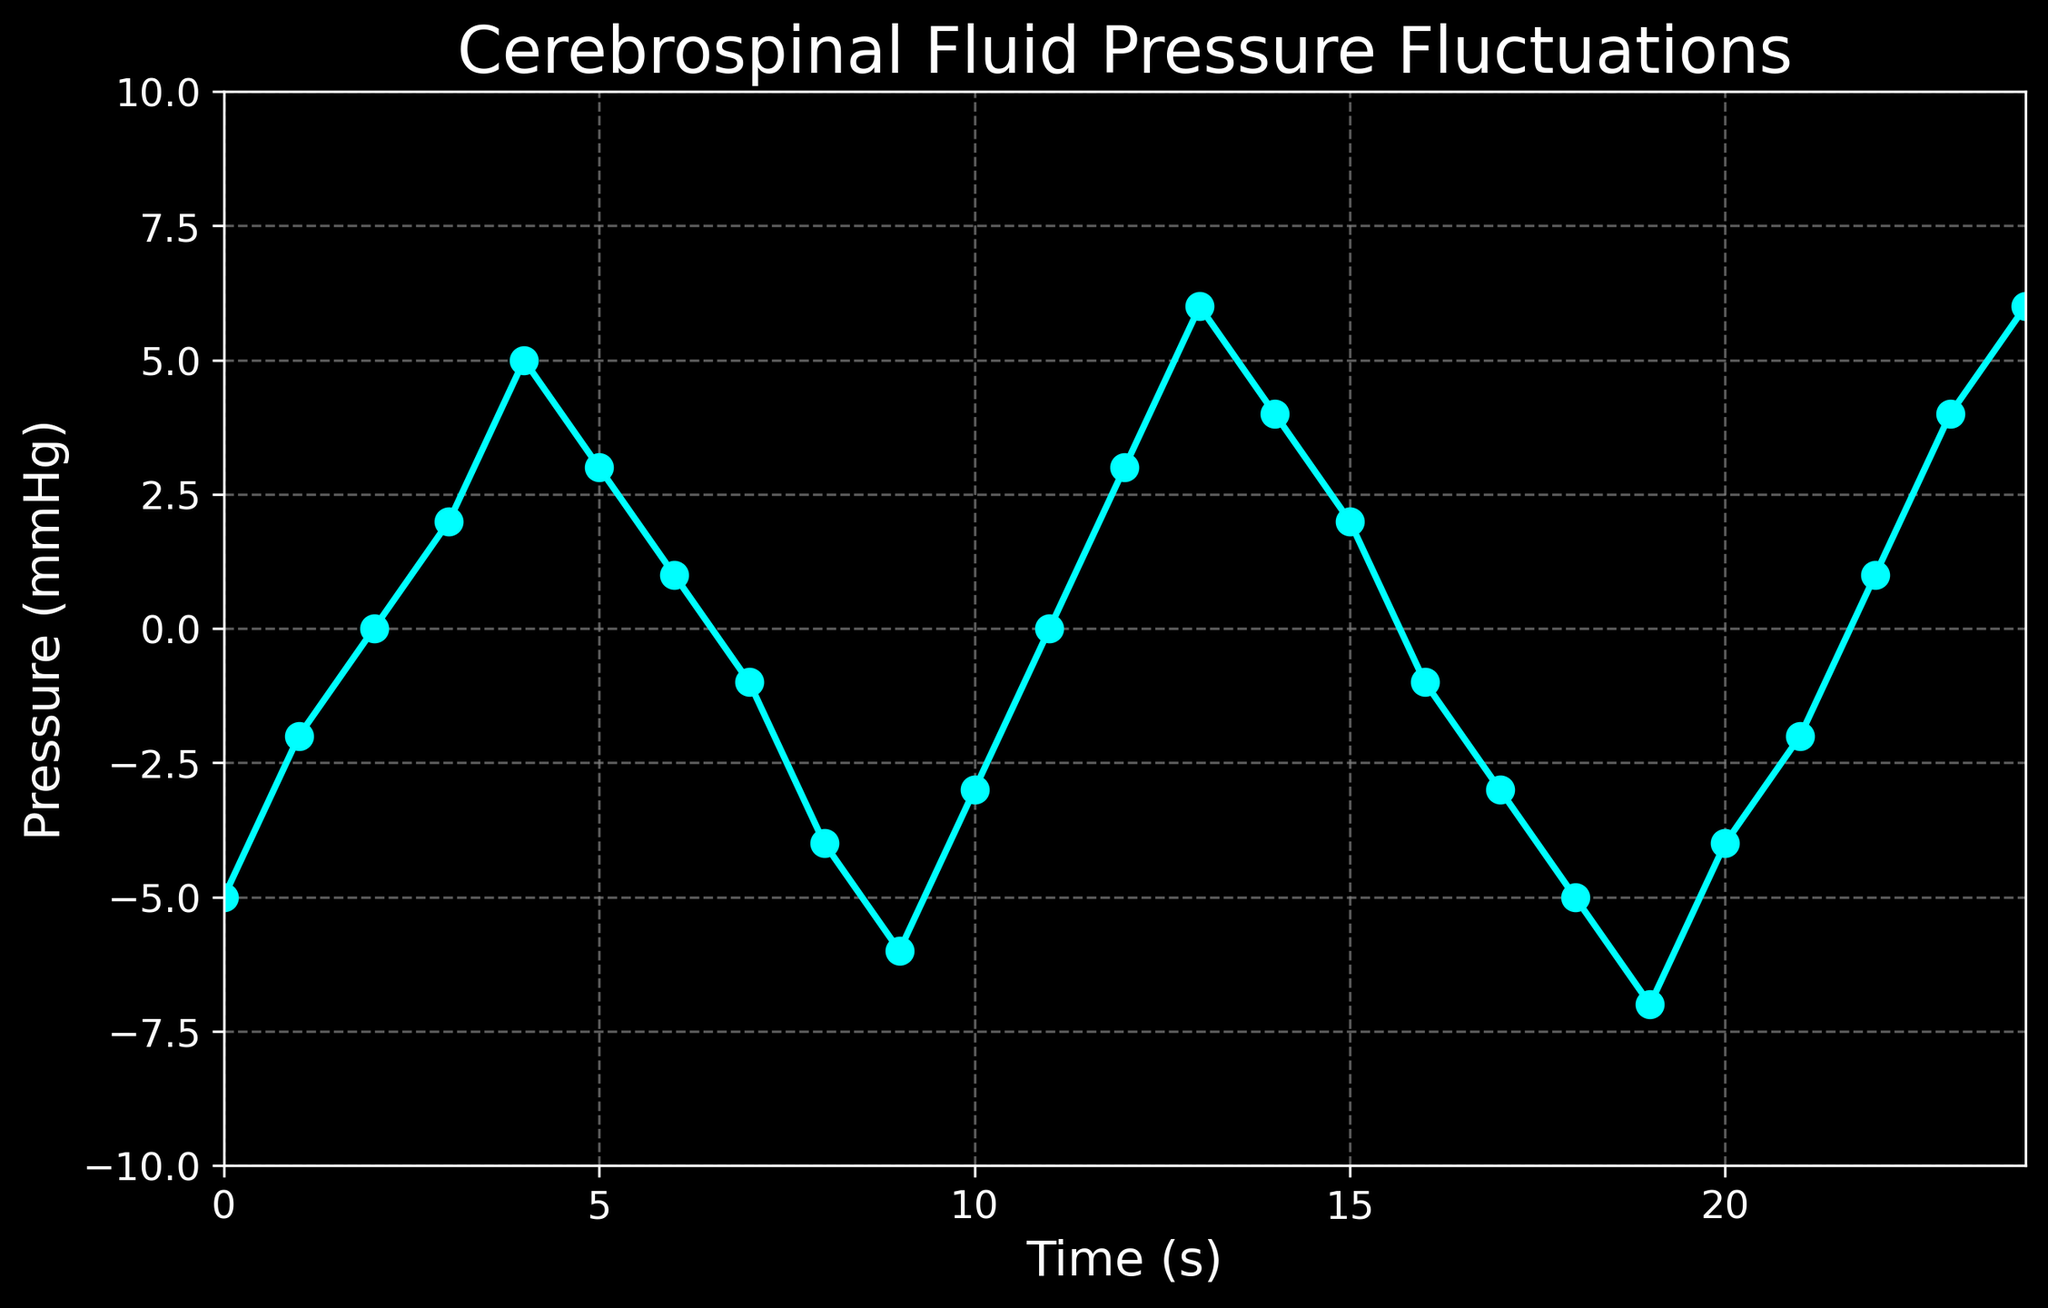What is the pressure at time 8 seconds? Look at the curve where the x-axis is 8 seconds and observe the corresponding y-axis value for pressure. You can see that it is -4 mmHg.
Answer: -4 mmHg What is the maximum pressure recorded, and at what time does it occur? Examine the pressure values throughout the entire graph and identify the highest point. The maximum pressure of 6 mmHg occurs at time 13 seconds and 24 seconds.
Answer: 6 mmHg at 13 seconds and 24 seconds What is the minimum pressure recorded, and at what time does it occur? Examine the pressure values throughout the entire graph and identify the lowest point. The minimum pressure of -7 mmHg occurs at time 19 seconds.
Answer: -7 mmHg at 19 seconds What is the average pressure value over the first 10 seconds? Sum the pressures from time 0 to 9 seconds and divide by the number of points (10). The values are -5, -2, 0, 2, 5, 3, 1, -1, -4, -6. The sum is -7, and the average is -7/10 = -0.7 mmHg.
Answer: -0.7 mmHg What is the difference in pressure between time 4 seconds and time 20 seconds? Subtract the pressure at time 20 seconds from the pressure at time 4 seconds. The values are 5 mmHg at 4 seconds and -4 mmHg at 20 seconds. The difference is 5 - (-4) = 9 mmHg.
Answer: 9 mmHg Between which two consecutive time points is the largest drop in pressure observed? Calculate the differences between consecutive pressure values and identify the largest negative difference. The largest drop is between time 24 and time 19 seconds with a change from 6 mmHg to -7 mmHg, a drop of 13 mmHg.
Answer: Between 13 seconds and 14 seconds (6 to -7 mmHg) Which time interval shows a transition from negative to positive pressure? Identify the points where the pressure goes from below zero to above zero. This occurs between time 1 second (pressure -2 mmHg) and time 2 seconds (pressure 0 mmHg). Another transition from negative to positive is from 21 seconds (-2 mmHg) to 22 seconds (1 mmHg).
Answer: Between 1 and 2 seconds and between 21 and 22 seconds What is the sum of pressure values at time points 3 seconds, 5 seconds, and 7 seconds? Add the pressure values at these specific time points: 2 mmHg at 3 seconds, 3 mmHg at 5 seconds, and -1 mmHg at 7 seconds. The sum is 2 + 3 - 1 = 4 mmHg.
Answer: 4 mmHg 